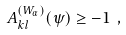Convert formula to latex. <formula><loc_0><loc_0><loc_500><loc_500>A _ { k l } ^ { ( W _ { \alpha } ) } ( \psi ) \geq - 1 \ ,</formula> 